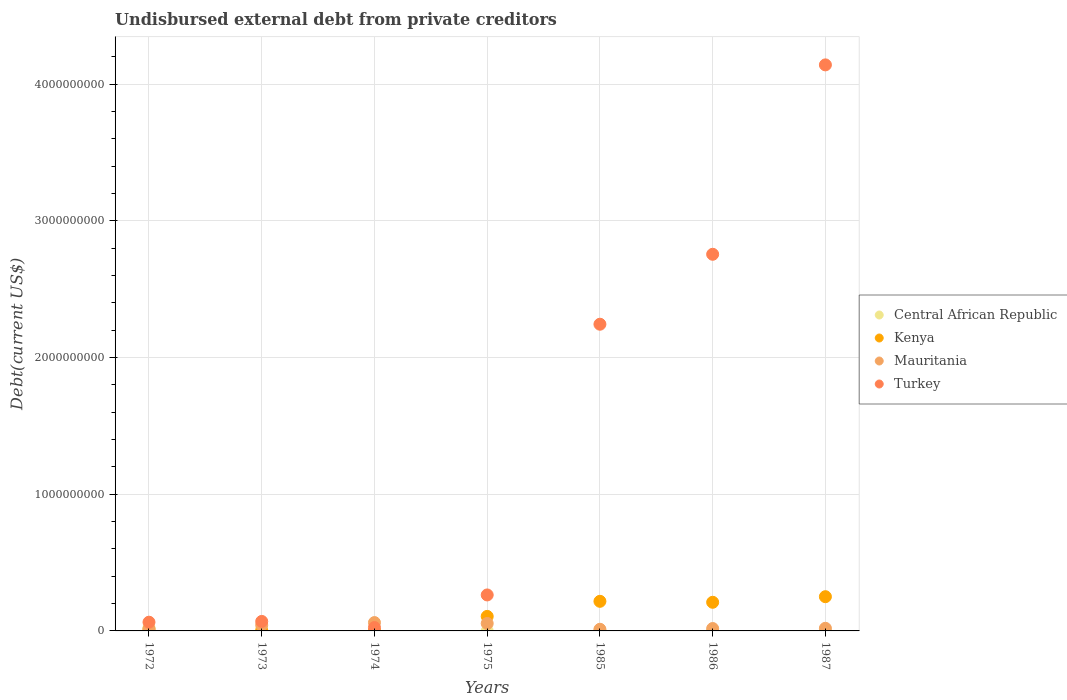Is the number of dotlines equal to the number of legend labels?
Your response must be concise. Yes. What is the total debt in Central African Republic in 1972?
Give a very brief answer. 2.36e+07. Across all years, what is the maximum total debt in Turkey?
Make the answer very short. 4.14e+09. Across all years, what is the minimum total debt in Mauritania?
Provide a short and direct response. 1.20e+07. In which year was the total debt in Kenya maximum?
Your answer should be very brief. 1987. In which year was the total debt in Central African Republic minimum?
Ensure brevity in your answer.  1975. What is the total total debt in Mauritania in the graph?
Keep it short and to the point. 2.21e+08. What is the difference between the total debt in Mauritania in 1972 and that in 1975?
Your answer should be very brief. -3.99e+07. What is the difference between the total debt in Kenya in 1973 and the total debt in Central African Republic in 1975?
Your response must be concise. 1.05e+06. What is the average total debt in Central African Republic per year?
Ensure brevity in your answer.  5.42e+06. In the year 1974, what is the difference between the total debt in Central African Republic and total debt in Kenya?
Offer a terse response. 9.98e+05. In how many years, is the total debt in Central African Republic greater than 2000000000 US$?
Offer a very short reply. 0. What is the ratio of the total debt in Kenya in 1973 to that in 1986?
Provide a succinct answer. 0.01. What is the difference between the highest and the second highest total debt in Mauritania?
Provide a succinct answer. 6.54e+06. What is the difference between the highest and the lowest total debt in Turkey?
Offer a terse response. 4.12e+09. In how many years, is the total debt in Turkey greater than the average total debt in Turkey taken over all years?
Ensure brevity in your answer.  3. Is it the case that in every year, the sum of the total debt in Central African Republic and total debt in Mauritania  is greater than the total debt in Kenya?
Your answer should be compact. No. How many dotlines are there?
Give a very brief answer. 4. How many years are there in the graph?
Offer a terse response. 7. What is the difference between two consecutive major ticks on the Y-axis?
Your answer should be very brief. 1.00e+09. Are the values on the major ticks of Y-axis written in scientific E-notation?
Your answer should be compact. No. Does the graph contain any zero values?
Offer a very short reply. No. How many legend labels are there?
Ensure brevity in your answer.  4. How are the legend labels stacked?
Give a very brief answer. Vertical. What is the title of the graph?
Give a very brief answer. Undisbursed external debt from private creditors. What is the label or title of the Y-axis?
Provide a short and direct response. Debt(current US$). What is the Debt(current US$) of Central African Republic in 1972?
Provide a short and direct response. 2.36e+07. What is the Debt(current US$) in Kenya in 1972?
Keep it short and to the point. 1.02e+07. What is the Debt(current US$) in Mauritania in 1972?
Your response must be concise. 1.46e+07. What is the Debt(current US$) of Turkey in 1972?
Offer a terse response. 6.39e+07. What is the Debt(current US$) of Central African Republic in 1973?
Offer a terse response. 7.28e+06. What is the Debt(current US$) of Kenya in 1973?
Keep it short and to the point. 1.21e+06. What is the Debt(current US$) in Mauritania in 1973?
Your answer should be very brief. 4.22e+07. What is the Debt(current US$) of Turkey in 1973?
Your answer should be compact. 6.95e+07. What is the Debt(current US$) of Central African Republic in 1974?
Your answer should be compact. 1.28e+06. What is the Debt(current US$) in Kenya in 1974?
Make the answer very short. 2.87e+05. What is the Debt(current US$) of Mauritania in 1974?
Provide a short and direct response. 6.10e+07. What is the Debt(current US$) in Turkey in 1974?
Make the answer very short. 2.46e+07. What is the Debt(current US$) in Central African Republic in 1975?
Provide a short and direct response. 1.62e+05. What is the Debt(current US$) in Kenya in 1975?
Make the answer very short. 1.06e+08. What is the Debt(current US$) in Mauritania in 1975?
Provide a short and direct response. 5.45e+07. What is the Debt(current US$) of Turkey in 1975?
Keep it short and to the point. 2.63e+08. What is the Debt(current US$) in Central African Republic in 1985?
Provide a short and direct response. 2.37e+06. What is the Debt(current US$) in Kenya in 1985?
Your response must be concise. 2.17e+08. What is the Debt(current US$) of Mauritania in 1985?
Provide a short and direct response. 1.20e+07. What is the Debt(current US$) of Turkey in 1985?
Your answer should be very brief. 2.24e+09. What is the Debt(current US$) of Central African Republic in 1986?
Keep it short and to the point. 1.96e+06. What is the Debt(current US$) of Kenya in 1986?
Provide a short and direct response. 2.09e+08. What is the Debt(current US$) in Mauritania in 1986?
Your answer should be compact. 1.75e+07. What is the Debt(current US$) of Turkey in 1986?
Your answer should be compact. 2.76e+09. What is the Debt(current US$) in Central African Republic in 1987?
Provide a short and direct response. 1.33e+06. What is the Debt(current US$) of Kenya in 1987?
Your answer should be compact. 2.50e+08. What is the Debt(current US$) of Mauritania in 1987?
Ensure brevity in your answer.  1.92e+07. What is the Debt(current US$) in Turkey in 1987?
Your answer should be compact. 4.14e+09. Across all years, what is the maximum Debt(current US$) in Central African Republic?
Ensure brevity in your answer.  2.36e+07. Across all years, what is the maximum Debt(current US$) in Kenya?
Ensure brevity in your answer.  2.50e+08. Across all years, what is the maximum Debt(current US$) of Mauritania?
Provide a succinct answer. 6.10e+07. Across all years, what is the maximum Debt(current US$) of Turkey?
Offer a very short reply. 4.14e+09. Across all years, what is the minimum Debt(current US$) in Central African Republic?
Keep it short and to the point. 1.62e+05. Across all years, what is the minimum Debt(current US$) of Kenya?
Give a very brief answer. 2.87e+05. Across all years, what is the minimum Debt(current US$) of Mauritania?
Make the answer very short. 1.20e+07. Across all years, what is the minimum Debt(current US$) of Turkey?
Ensure brevity in your answer.  2.46e+07. What is the total Debt(current US$) of Central African Republic in the graph?
Ensure brevity in your answer.  3.80e+07. What is the total Debt(current US$) of Kenya in the graph?
Provide a succinct answer. 7.94e+08. What is the total Debt(current US$) of Mauritania in the graph?
Offer a terse response. 2.21e+08. What is the total Debt(current US$) of Turkey in the graph?
Your answer should be compact. 9.56e+09. What is the difference between the Debt(current US$) of Central African Republic in 1972 and that in 1973?
Ensure brevity in your answer.  1.63e+07. What is the difference between the Debt(current US$) of Kenya in 1972 and that in 1973?
Your answer should be very brief. 8.96e+06. What is the difference between the Debt(current US$) of Mauritania in 1972 and that in 1973?
Offer a terse response. -2.76e+07. What is the difference between the Debt(current US$) in Turkey in 1972 and that in 1973?
Give a very brief answer. -5.62e+06. What is the difference between the Debt(current US$) of Central African Republic in 1972 and that in 1974?
Ensure brevity in your answer.  2.23e+07. What is the difference between the Debt(current US$) in Kenya in 1972 and that in 1974?
Offer a very short reply. 9.88e+06. What is the difference between the Debt(current US$) of Mauritania in 1972 and that in 1974?
Your answer should be compact. -4.65e+07. What is the difference between the Debt(current US$) in Turkey in 1972 and that in 1974?
Your answer should be very brief. 3.93e+07. What is the difference between the Debt(current US$) in Central African Republic in 1972 and that in 1975?
Provide a short and direct response. 2.34e+07. What is the difference between the Debt(current US$) of Kenya in 1972 and that in 1975?
Offer a very short reply. -9.60e+07. What is the difference between the Debt(current US$) of Mauritania in 1972 and that in 1975?
Your response must be concise. -3.99e+07. What is the difference between the Debt(current US$) of Turkey in 1972 and that in 1975?
Keep it short and to the point. -1.99e+08. What is the difference between the Debt(current US$) in Central African Republic in 1972 and that in 1985?
Offer a terse response. 2.12e+07. What is the difference between the Debt(current US$) of Kenya in 1972 and that in 1985?
Offer a very short reply. -2.06e+08. What is the difference between the Debt(current US$) of Mauritania in 1972 and that in 1985?
Offer a terse response. 2.56e+06. What is the difference between the Debt(current US$) of Turkey in 1972 and that in 1985?
Provide a short and direct response. -2.18e+09. What is the difference between the Debt(current US$) in Central African Republic in 1972 and that in 1986?
Provide a short and direct response. 2.16e+07. What is the difference between the Debt(current US$) in Kenya in 1972 and that in 1986?
Provide a short and direct response. -1.99e+08. What is the difference between the Debt(current US$) in Mauritania in 1972 and that in 1986?
Offer a very short reply. -2.92e+06. What is the difference between the Debt(current US$) in Turkey in 1972 and that in 1986?
Give a very brief answer. -2.69e+09. What is the difference between the Debt(current US$) of Central African Republic in 1972 and that in 1987?
Keep it short and to the point. 2.23e+07. What is the difference between the Debt(current US$) in Kenya in 1972 and that in 1987?
Ensure brevity in your answer.  -2.40e+08. What is the difference between the Debt(current US$) in Mauritania in 1972 and that in 1987?
Make the answer very short. -4.64e+06. What is the difference between the Debt(current US$) of Turkey in 1972 and that in 1987?
Offer a very short reply. -4.08e+09. What is the difference between the Debt(current US$) in Central African Republic in 1973 and that in 1974?
Provide a short and direct response. 6.00e+06. What is the difference between the Debt(current US$) in Kenya in 1973 and that in 1974?
Offer a very short reply. 9.26e+05. What is the difference between the Debt(current US$) in Mauritania in 1973 and that in 1974?
Make the answer very short. -1.89e+07. What is the difference between the Debt(current US$) in Turkey in 1973 and that in 1974?
Your response must be concise. 4.49e+07. What is the difference between the Debt(current US$) in Central African Republic in 1973 and that in 1975?
Your response must be concise. 7.12e+06. What is the difference between the Debt(current US$) of Kenya in 1973 and that in 1975?
Ensure brevity in your answer.  -1.05e+08. What is the difference between the Debt(current US$) of Mauritania in 1973 and that in 1975?
Offer a very short reply. -1.23e+07. What is the difference between the Debt(current US$) in Turkey in 1973 and that in 1975?
Provide a short and direct response. -1.94e+08. What is the difference between the Debt(current US$) of Central African Republic in 1973 and that in 1985?
Offer a terse response. 4.91e+06. What is the difference between the Debt(current US$) in Kenya in 1973 and that in 1985?
Provide a succinct answer. -2.15e+08. What is the difference between the Debt(current US$) of Mauritania in 1973 and that in 1985?
Offer a very short reply. 3.01e+07. What is the difference between the Debt(current US$) of Turkey in 1973 and that in 1985?
Offer a terse response. -2.17e+09. What is the difference between the Debt(current US$) of Central African Republic in 1973 and that in 1986?
Ensure brevity in your answer.  5.33e+06. What is the difference between the Debt(current US$) of Kenya in 1973 and that in 1986?
Your response must be concise. -2.08e+08. What is the difference between the Debt(current US$) in Mauritania in 1973 and that in 1986?
Make the answer very short. 2.47e+07. What is the difference between the Debt(current US$) of Turkey in 1973 and that in 1986?
Keep it short and to the point. -2.69e+09. What is the difference between the Debt(current US$) of Central African Republic in 1973 and that in 1987?
Give a very brief answer. 5.96e+06. What is the difference between the Debt(current US$) of Kenya in 1973 and that in 1987?
Offer a very short reply. -2.49e+08. What is the difference between the Debt(current US$) of Mauritania in 1973 and that in 1987?
Your answer should be very brief. 2.29e+07. What is the difference between the Debt(current US$) in Turkey in 1973 and that in 1987?
Your response must be concise. -4.07e+09. What is the difference between the Debt(current US$) of Central African Republic in 1974 and that in 1975?
Your answer should be very brief. 1.12e+06. What is the difference between the Debt(current US$) of Kenya in 1974 and that in 1975?
Ensure brevity in your answer.  -1.06e+08. What is the difference between the Debt(current US$) in Mauritania in 1974 and that in 1975?
Ensure brevity in your answer.  6.54e+06. What is the difference between the Debt(current US$) of Turkey in 1974 and that in 1975?
Offer a very short reply. -2.39e+08. What is the difference between the Debt(current US$) in Central African Republic in 1974 and that in 1985?
Your answer should be compact. -1.09e+06. What is the difference between the Debt(current US$) of Kenya in 1974 and that in 1985?
Keep it short and to the point. -2.16e+08. What is the difference between the Debt(current US$) of Mauritania in 1974 and that in 1985?
Your response must be concise. 4.90e+07. What is the difference between the Debt(current US$) of Turkey in 1974 and that in 1985?
Your answer should be very brief. -2.22e+09. What is the difference between the Debt(current US$) in Central African Republic in 1974 and that in 1986?
Your answer should be very brief. -6.71e+05. What is the difference between the Debt(current US$) of Kenya in 1974 and that in 1986?
Give a very brief answer. -2.09e+08. What is the difference between the Debt(current US$) in Mauritania in 1974 and that in 1986?
Offer a terse response. 4.35e+07. What is the difference between the Debt(current US$) of Turkey in 1974 and that in 1986?
Ensure brevity in your answer.  -2.73e+09. What is the difference between the Debt(current US$) in Central African Republic in 1974 and that in 1987?
Keep it short and to the point. -4.30e+04. What is the difference between the Debt(current US$) of Kenya in 1974 and that in 1987?
Keep it short and to the point. -2.50e+08. What is the difference between the Debt(current US$) of Mauritania in 1974 and that in 1987?
Ensure brevity in your answer.  4.18e+07. What is the difference between the Debt(current US$) in Turkey in 1974 and that in 1987?
Offer a very short reply. -4.12e+09. What is the difference between the Debt(current US$) in Central African Republic in 1975 and that in 1985?
Provide a short and direct response. -2.21e+06. What is the difference between the Debt(current US$) in Kenya in 1975 and that in 1985?
Offer a very short reply. -1.10e+08. What is the difference between the Debt(current US$) of Mauritania in 1975 and that in 1985?
Provide a short and direct response. 4.25e+07. What is the difference between the Debt(current US$) in Turkey in 1975 and that in 1985?
Your answer should be compact. -1.98e+09. What is the difference between the Debt(current US$) of Central African Republic in 1975 and that in 1986?
Keep it short and to the point. -1.79e+06. What is the difference between the Debt(current US$) of Kenya in 1975 and that in 1986?
Ensure brevity in your answer.  -1.03e+08. What is the difference between the Debt(current US$) of Mauritania in 1975 and that in 1986?
Offer a terse response. 3.70e+07. What is the difference between the Debt(current US$) in Turkey in 1975 and that in 1986?
Your response must be concise. -2.49e+09. What is the difference between the Debt(current US$) of Central African Republic in 1975 and that in 1987?
Provide a short and direct response. -1.17e+06. What is the difference between the Debt(current US$) of Kenya in 1975 and that in 1987?
Your answer should be compact. -1.44e+08. What is the difference between the Debt(current US$) in Mauritania in 1975 and that in 1987?
Provide a succinct answer. 3.53e+07. What is the difference between the Debt(current US$) in Turkey in 1975 and that in 1987?
Provide a succinct answer. -3.88e+09. What is the difference between the Debt(current US$) of Central African Republic in 1985 and that in 1986?
Your answer should be compact. 4.17e+05. What is the difference between the Debt(current US$) in Kenya in 1985 and that in 1986?
Keep it short and to the point. 7.08e+06. What is the difference between the Debt(current US$) of Mauritania in 1985 and that in 1986?
Your response must be concise. -5.48e+06. What is the difference between the Debt(current US$) in Turkey in 1985 and that in 1986?
Give a very brief answer. -5.12e+08. What is the difference between the Debt(current US$) in Central African Republic in 1985 and that in 1987?
Make the answer very short. 1.04e+06. What is the difference between the Debt(current US$) in Kenya in 1985 and that in 1987?
Your answer should be very brief. -3.38e+07. What is the difference between the Debt(current US$) in Mauritania in 1985 and that in 1987?
Give a very brief answer. -7.21e+06. What is the difference between the Debt(current US$) in Turkey in 1985 and that in 1987?
Your response must be concise. -1.90e+09. What is the difference between the Debt(current US$) of Central African Republic in 1986 and that in 1987?
Ensure brevity in your answer.  6.28e+05. What is the difference between the Debt(current US$) of Kenya in 1986 and that in 1987?
Provide a short and direct response. -4.09e+07. What is the difference between the Debt(current US$) of Mauritania in 1986 and that in 1987?
Offer a very short reply. -1.73e+06. What is the difference between the Debt(current US$) of Turkey in 1986 and that in 1987?
Your answer should be very brief. -1.39e+09. What is the difference between the Debt(current US$) of Central African Republic in 1972 and the Debt(current US$) of Kenya in 1973?
Ensure brevity in your answer.  2.24e+07. What is the difference between the Debt(current US$) of Central African Republic in 1972 and the Debt(current US$) of Mauritania in 1973?
Ensure brevity in your answer.  -1.86e+07. What is the difference between the Debt(current US$) of Central African Republic in 1972 and the Debt(current US$) of Turkey in 1973?
Your answer should be compact. -4.59e+07. What is the difference between the Debt(current US$) in Kenya in 1972 and the Debt(current US$) in Mauritania in 1973?
Your answer should be very brief. -3.20e+07. What is the difference between the Debt(current US$) of Kenya in 1972 and the Debt(current US$) of Turkey in 1973?
Make the answer very short. -5.93e+07. What is the difference between the Debt(current US$) of Mauritania in 1972 and the Debt(current US$) of Turkey in 1973?
Offer a very short reply. -5.49e+07. What is the difference between the Debt(current US$) of Central African Republic in 1972 and the Debt(current US$) of Kenya in 1974?
Offer a terse response. 2.33e+07. What is the difference between the Debt(current US$) of Central African Republic in 1972 and the Debt(current US$) of Mauritania in 1974?
Offer a very short reply. -3.75e+07. What is the difference between the Debt(current US$) in Central African Republic in 1972 and the Debt(current US$) in Turkey in 1974?
Your response must be concise. -1.01e+06. What is the difference between the Debt(current US$) in Kenya in 1972 and the Debt(current US$) in Mauritania in 1974?
Offer a very short reply. -5.09e+07. What is the difference between the Debt(current US$) in Kenya in 1972 and the Debt(current US$) in Turkey in 1974?
Give a very brief answer. -1.44e+07. What is the difference between the Debt(current US$) in Mauritania in 1972 and the Debt(current US$) in Turkey in 1974?
Keep it short and to the point. -1.00e+07. What is the difference between the Debt(current US$) of Central African Republic in 1972 and the Debt(current US$) of Kenya in 1975?
Your answer should be compact. -8.26e+07. What is the difference between the Debt(current US$) of Central African Republic in 1972 and the Debt(current US$) of Mauritania in 1975?
Make the answer very short. -3.09e+07. What is the difference between the Debt(current US$) of Central African Republic in 1972 and the Debt(current US$) of Turkey in 1975?
Keep it short and to the point. -2.40e+08. What is the difference between the Debt(current US$) of Kenya in 1972 and the Debt(current US$) of Mauritania in 1975?
Provide a succinct answer. -4.43e+07. What is the difference between the Debt(current US$) of Kenya in 1972 and the Debt(current US$) of Turkey in 1975?
Your answer should be compact. -2.53e+08. What is the difference between the Debt(current US$) of Mauritania in 1972 and the Debt(current US$) of Turkey in 1975?
Ensure brevity in your answer.  -2.49e+08. What is the difference between the Debt(current US$) in Central African Republic in 1972 and the Debt(current US$) in Kenya in 1985?
Provide a succinct answer. -1.93e+08. What is the difference between the Debt(current US$) of Central African Republic in 1972 and the Debt(current US$) of Mauritania in 1985?
Provide a succinct answer. 1.16e+07. What is the difference between the Debt(current US$) of Central African Republic in 1972 and the Debt(current US$) of Turkey in 1985?
Provide a succinct answer. -2.22e+09. What is the difference between the Debt(current US$) of Kenya in 1972 and the Debt(current US$) of Mauritania in 1985?
Your response must be concise. -1.85e+06. What is the difference between the Debt(current US$) in Kenya in 1972 and the Debt(current US$) in Turkey in 1985?
Offer a very short reply. -2.23e+09. What is the difference between the Debt(current US$) of Mauritania in 1972 and the Debt(current US$) of Turkey in 1985?
Offer a terse response. -2.23e+09. What is the difference between the Debt(current US$) in Central African Republic in 1972 and the Debt(current US$) in Kenya in 1986?
Ensure brevity in your answer.  -1.86e+08. What is the difference between the Debt(current US$) of Central African Republic in 1972 and the Debt(current US$) of Mauritania in 1986?
Offer a very short reply. 6.08e+06. What is the difference between the Debt(current US$) in Central African Republic in 1972 and the Debt(current US$) in Turkey in 1986?
Ensure brevity in your answer.  -2.73e+09. What is the difference between the Debt(current US$) in Kenya in 1972 and the Debt(current US$) in Mauritania in 1986?
Offer a very short reply. -7.34e+06. What is the difference between the Debt(current US$) of Kenya in 1972 and the Debt(current US$) of Turkey in 1986?
Offer a terse response. -2.74e+09. What is the difference between the Debt(current US$) of Mauritania in 1972 and the Debt(current US$) of Turkey in 1986?
Keep it short and to the point. -2.74e+09. What is the difference between the Debt(current US$) of Central African Republic in 1972 and the Debt(current US$) of Kenya in 1987?
Provide a short and direct response. -2.27e+08. What is the difference between the Debt(current US$) in Central African Republic in 1972 and the Debt(current US$) in Mauritania in 1987?
Provide a succinct answer. 4.35e+06. What is the difference between the Debt(current US$) of Central African Republic in 1972 and the Debt(current US$) of Turkey in 1987?
Your response must be concise. -4.12e+09. What is the difference between the Debt(current US$) of Kenya in 1972 and the Debt(current US$) of Mauritania in 1987?
Keep it short and to the point. -9.06e+06. What is the difference between the Debt(current US$) in Kenya in 1972 and the Debt(current US$) in Turkey in 1987?
Give a very brief answer. -4.13e+09. What is the difference between the Debt(current US$) in Mauritania in 1972 and the Debt(current US$) in Turkey in 1987?
Offer a very short reply. -4.13e+09. What is the difference between the Debt(current US$) of Central African Republic in 1973 and the Debt(current US$) of Kenya in 1974?
Your answer should be compact. 7.00e+06. What is the difference between the Debt(current US$) in Central African Republic in 1973 and the Debt(current US$) in Mauritania in 1974?
Offer a terse response. -5.38e+07. What is the difference between the Debt(current US$) in Central African Republic in 1973 and the Debt(current US$) in Turkey in 1974?
Make the answer very short. -1.73e+07. What is the difference between the Debt(current US$) of Kenya in 1973 and the Debt(current US$) of Mauritania in 1974?
Make the answer very short. -5.98e+07. What is the difference between the Debt(current US$) in Kenya in 1973 and the Debt(current US$) in Turkey in 1974?
Keep it short and to the point. -2.34e+07. What is the difference between the Debt(current US$) in Mauritania in 1973 and the Debt(current US$) in Turkey in 1974?
Keep it short and to the point. 1.76e+07. What is the difference between the Debt(current US$) of Central African Republic in 1973 and the Debt(current US$) of Kenya in 1975?
Provide a short and direct response. -9.89e+07. What is the difference between the Debt(current US$) of Central African Republic in 1973 and the Debt(current US$) of Mauritania in 1975?
Offer a very short reply. -4.72e+07. What is the difference between the Debt(current US$) of Central African Republic in 1973 and the Debt(current US$) of Turkey in 1975?
Offer a terse response. -2.56e+08. What is the difference between the Debt(current US$) of Kenya in 1973 and the Debt(current US$) of Mauritania in 1975?
Offer a terse response. -5.33e+07. What is the difference between the Debt(current US$) of Kenya in 1973 and the Debt(current US$) of Turkey in 1975?
Make the answer very short. -2.62e+08. What is the difference between the Debt(current US$) in Mauritania in 1973 and the Debt(current US$) in Turkey in 1975?
Your answer should be compact. -2.21e+08. What is the difference between the Debt(current US$) of Central African Republic in 1973 and the Debt(current US$) of Kenya in 1985?
Make the answer very short. -2.09e+08. What is the difference between the Debt(current US$) of Central African Republic in 1973 and the Debt(current US$) of Mauritania in 1985?
Provide a succinct answer. -4.74e+06. What is the difference between the Debt(current US$) in Central African Republic in 1973 and the Debt(current US$) in Turkey in 1985?
Ensure brevity in your answer.  -2.24e+09. What is the difference between the Debt(current US$) of Kenya in 1973 and the Debt(current US$) of Mauritania in 1985?
Provide a succinct answer. -1.08e+07. What is the difference between the Debt(current US$) of Kenya in 1973 and the Debt(current US$) of Turkey in 1985?
Provide a succinct answer. -2.24e+09. What is the difference between the Debt(current US$) in Mauritania in 1973 and the Debt(current US$) in Turkey in 1985?
Your answer should be compact. -2.20e+09. What is the difference between the Debt(current US$) of Central African Republic in 1973 and the Debt(current US$) of Kenya in 1986?
Make the answer very short. -2.02e+08. What is the difference between the Debt(current US$) of Central African Republic in 1973 and the Debt(current US$) of Mauritania in 1986?
Your answer should be very brief. -1.02e+07. What is the difference between the Debt(current US$) of Central African Republic in 1973 and the Debt(current US$) of Turkey in 1986?
Provide a short and direct response. -2.75e+09. What is the difference between the Debt(current US$) of Kenya in 1973 and the Debt(current US$) of Mauritania in 1986?
Your answer should be compact. -1.63e+07. What is the difference between the Debt(current US$) in Kenya in 1973 and the Debt(current US$) in Turkey in 1986?
Offer a very short reply. -2.75e+09. What is the difference between the Debt(current US$) of Mauritania in 1973 and the Debt(current US$) of Turkey in 1986?
Provide a succinct answer. -2.71e+09. What is the difference between the Debt(current US$) in Central African Republic in 1973 and the Debt(current US$) in Kenya in 1987?
Your answer should be compact. -2.43e+08. What is the difference between the Debt(current US$) of Central African Republic in 1973 and the Debt(current US$) of Mauritania in 1987?
Keep it short and to the point. -1.19e+07. What is the difference between the Debt(current US$) of Central African Republic in 1973 and the Debt(current US$) of Turkey in 1987?
Your response must be concise. -4.13e+09. What is the difference between the Debt(current US$) of Kenya in 1973 and the Debt(current US$) of Mauritania in 1987?
Offer a very short reply. -1.80e+07. What is the difference between the Debt(current US$) in Kenya in 1973 and the Debt(current US$) in Turkey in 1987?
Your answer should be very brief. -4.14e+09. What is the difference between the Debt(current US$) of Mauritania in 1973 and the Debt(current US$) of Turkey in 1987?
Your response must be concise. -4.10e+09. What is the difference between the Debt(current US$) in Central African Republic in 1974 and the Debt(current US$) in Kenya in 1975?
Give a very brief answer. -1.05e+08. What is the difference between the Debt(current US$) in Central African Republic in 1974 and the Debt(current US$) in Mauritania in 1975?
Offer a terse response. -5.32e+07. What is the difference between the Debt(current US$) in Central African Republic in 1974 and the Debt(current US$) in Turkey in 1975?
Your answer should be very brief. -2.62e+08. What is the difference between the Debt(current US$) of Kenya in 1974 and the Debt(current US$) of Mauritania in 1975?
Your answer should be compact. -5.42e+07. What is the difference between the Debt(current US$) in Kenya in 1974 and the Debt(current US$) in Turkey in 1975?
Provide a short and direct response. -2.63e+08. What is the difference between the Debt(current US$) of Mauritania in 1974 and the Debt(current US$) of Turkey in 1975?
Your answer should be compact. -2.02e+08. What is the difference between the Debt(current US$) in Central African Republic in 1974 and the Debt(current US$) in Kenya in 1985?
Your answer should be compact. -2.15e+08. What is the difference between the Debt(current US$) of Central African Republic in 1974 and the Debt(current US$) of Mauritania in 1985?
Your answer should be compact. -1.07e+07. What is the difference between the Debt(current US$) of Central African Republic in 1974 and the Debt(current US$) of Turkey in 1985?
Make the answer very short. -2.24e+09. What is the difference between the Debt(current US$) in Kenya in 1974 and the Debt(current US$) in Mauritania in 1985?
Give a very brief answer. -1.17e+07. What is the difference between the Debt(current US$) of Kenya in 1974 and the Debt(current US$) of Turkey in 1985?
Give a very brief answer. -2.24e+09. What is the difference between the Debt(current US$) in Mauritania in 1974 and the Debt(current US$) in Turkey in 1985?
Your answer should be compact. -2.18e+09. What is the difference between the Debt(current US$) in Central African Republic in 1974 and the Debt(current US$) in Kenya in 1986?
Ensure brevity in your answer.  -2.08e+08. What is the difference between the Debt(current US$) in Central African Republic in 1974 and the Debt(current US$) in Mauritania in 1986?
Give a very brief answer. -1.62e+07. What is the difference between the Debt(current US$) of Central African Republic in 1974 and the Debt(current US$) of Turkey in 1986?
Keep it short and to the point. -2.75e+09. What is the difference between the Debt(current US$) of Kenya in 1974 and the Debt(current US$) of Mauritania in 1986?
Your response must be concise. -1.72e+07. What is the difference between the Debt(current US$) in Kenya in 1974 and the Debt(current US$) in Turkey in 1986?
Offer a very short reply. -2.75e+09. What is the difference between the Debt(current US$) of Mauritania in 1974 and the Debt(current US$) of Turkey in 1986?
Provide a short and direct response. -2.69e+09. What is the difference between the Debt(current US$) in Central African Republic in 1974 and the Debt(current US$) in Kenya in 1987?
Your answer should be very brief. -2.49e+08. What is the difference between the Debt(current US$) of Central African Republic in 1974 and the Debt(current US$) of Mauritania in 1987?
Provide a succinct answer. -1.79e+07. What is the difference between the Debt(current US$) of Central African Republic in 1974 and the Debt(current US$) of Turkey in 1987?
Ensure brevity in your answer.  -4.14e+09. What is the difference between the Debt(current US$) of Kenya in 1974 and the Debt(current US$) of Mauritania in 1987?
Ensure brevity in your answer.  -1.89e+07. What is the difference between the Debt(current US$) in Kenya in 1974 and the Debt(current US$) in Turkey in 1987?
Give a very brief answer. -4.14e+09. What is the difference between the Debt(current US$) of Mauritania in 1974 and the Debt(current US$) of Turkey in 1987?
Your answer should be very brief. -4.08e+09. What is the difference between the Debt(current US$) of Central African Republic in 1975 and the Debt(current US$) of Kenya in 1985?
Offer a very short reply. -2.16e+08. What is the difference between the Debt(current US$) in Central African Republic in 1975 and the Debt(current US$) in Mauritania in 1985?
Keep it short and to the point. -1.19e+07. What is the difference between the Debt(current US$) of Central African Republic in 1975 and the Debt(current US$) of Turkey in 1985?
Offer a very short reply. -2.24e+09. What is the difference between the Debt(current US$) of Kenya in 1975 and the Debt(current US$) of Mauritania in 1985?
Provide a short and direct response. 9.42e+07. What is the difference between the Debt(current US$) of Kenya in 1975 and the Debt(current US$) of Turkey in 1985?
Provide a succinct answer. -2.14e+09. What is the difference between the Debt(current US$) in Mauritania in 1975 and the Debt(current US$) in Turkey in 1985?
Offer a very short reply. -2.19e+09. What is the difference between the Debt(current US$) in Central African Republic in 1975 and the Debt(current US$) in Kenya in 1986?
Make the answer very short. -2.09e+08. What is the difference between the Debt(current US$) in Central African Republic in 1975 and the Debt(current US$) in Mauritania in 1986?
Your answer should be compact. -1.73e+07. What is the difference between the Debt(current US$) of Central African Republic in 1975 and the Debt(current US$) of Turkey in 1986?
Provide a short and direct response. -2.76e+09. What is the difference between the Debt(current US$) in Kenya in 1975 and the Debt(current US$) in Mauritania in 1986?
Keep it short and to the point. 8.87e+07. What is the difference between the Debt(current US$) of Kenya in 1975 and the Debt(current US$) of Turkey in 1986?
Provide a short and direct response. -2.65e+09. What is the difference between the Debt(current US$) of Mauritania in 1975 and the Debt(current US$) of Turkey in 1986?
Your answer should be compact. -2.70e+09. What is the difference between the Debt(current US$) in Central African Republic in 1975 and the Debt(current US$) in Kenya in 1987?
Your response must be concise. -2.50e+08. What is the difference between the Debt(current US$) of Central African Republic in 1975 and the Debt(current US$) of Mauritania in 1987?
Ensure brevity in your answer.  -1.91e+07. What is the difference between the Debt(current US$) in Central African Republic in 1975 and the Debt(current US$) in Turkey in 1987?
Offer a very short reply. -4.14e+09. What is the difference between the Debt(current US$) in Kenya in 1975 and the Debt(current US$) in Mauritania in 1987?
Offer a terse response. 8.70e+07. What is the difference between the Debt(current US$) in Kenya in 1975 and the Debt(current US$) in Turkey in 1987?
Ensure brevity in your answer.  -4.03e+09. What is the difference between the Debt(current US$) of Mauritania in 1975 and the Debt(current US$) of Turkey in 1987?
Your answer should be very brief. -4.09e+09. What is the difference between the Debt(current US$) in Central African Republic in 1985 and the Debt(current US$) in Kenya in 1986?
Provide a short and direct response. -2.07e+08. What is the difference between the Debt(current US$) in Central African Republic in 1985 and the Debt(current US$) in Mauritania in 1986?
Your answer should be compact. -1.51e+07. What is the difference between the Debt(current US$) of Central African Republic in 1985 and the Debt(current US$) of Turkey in 1986?
Offer a terse response. -2.75e+09. What is the difference between the Debt(current US$) in Kenya in 1985 and the Debt(current US$) in Mauritania in 1986?
Your answer should be compact. 1.99e+08. What is the difference between the Debt(current US$) in Kenya in 1985 and the Debt(current US$) in Turkey in 1986?
Offer a very short reply. -2.54e+09. What is the difference between the Debt(current US$) of Mauritania in 1985 and the Debt(current US$) of Turkey in 1986?
Provide a short and direct response. -2.74e+09. What is the difference between the Debt(current US$) in Central African Republic in 1985 and the Debt(current US$) in Kenya in 1987?
Your answer should be very brief. -2.48e+08. What is the difference between the Debt(current US$) of Central African Republic in 1985 and the Debt(current US$) of Mauritania in 1987?
Offer a terse response. -1.69e+07. What is the difference between the Debt(current US$) of Central African Republic in 1985 and the Debt(current US$) of Turkey in 1987?
Ensure brevity in your answer.  -4.14e+09. What is the difference between the Debt(current US$) of Kenya in 1985 and the Debt(current US$) of Mauritania in 1987?
Your answer should be compact. 1.97e+08. What is the difference between the Debt(current US$) in Kenya in 1985 and the Debt(current US$) in Turkey in 1987?
Provide a succinct answer. -3.92e+09. What is the difference between the Debt(current US$) in Mauritania in 1985 and the Debt(current US$) in Turkey in 1987?
Offer a very short reply. -4.13e+09. What is the difference between the Debt(current US$) in Central African Republic in 1986 and the Debt(current US$) in Kenya in 1987?
Give a very brief answer. -2.48e+08. What is the difference between the Debt(current US$) of Central African Republic in 1986 and the Debt(current US$) of Mauritania in 1987?
Provide a succinct answer. -1.73e+07. What is the difference between the Debt(current US$) in Central African Republic in 1986 and the Debt(current US$) in Turkey in 1987?
Your answer should be very brief. -4.14e+09. What is the difference between the Debt(current US$) of Kenya in 1986 and the Debt(current US$) of Mauritania in 1987?
Keep it short and to the point. 1.90e+08. What is the difference between the Debt(current US$) in Kenya in 1986 and the Debt(current US$) in Turkey in 1987?
Your answer should be very brief. -3.93e+09. What is the difference between the Debt(current US$) in Mauritania in 1986 and the Debt(current US$) in Turkey in 1987?
Offer a very short reply. -4.12e+09. What is the average Debt(current US$) of Central African Republic per year?
Make the answer very short. 5.42e+06. What is the average Debt(current US$) in Kenya per year?
Your response must be concise. 1.13e+08. What is the average Debt(current US$) of Mauritania per year?
Your answer should be very brief. 3.16e+07. What is the average Debt(current US$) in Turkey per year?
Offer a very short reply. 1.37e+09. In the year 1972, what is the difference between the Debt(current US$) of Central African Republic and Debt(current US$) of Kenya?
Your response must be concise. 1.34e+07. In the year 1972, what is the difference between the Debt(current US$) in Central African Republic and Debt(current US$) in Mauritania?
Your answer should be compact. 9.00e+06. In the year 1972, what is the difference between the Debt(current US$) of Central African Republic and Debt(current US$) of Turkey?
Your answer should be very brief. -4.03e+07. In the year 1972, what is the difference between the Debt(current US$) of Kenya and Debt(current US$) of Mauritania?
Give a very brief answer. -4.42e+06. In the year 1972, what is the difference between the Debt(current US$) in Kenya and Debt(current US$) in Turkey?
Offer a terse response. -5.37e+07. In the year 1972, what is the difference between the Debt(current US$) of Mauritania and Debt(current US$) of Turkey?
Your answer should be compact. -4.93e+07. In the year 1973, what is the difference between the Debt(current US$) in Central African Republic and Debt(current US$) in Kenya?
Your answer should be very brief. 6.07e+06. In the year 1973, what is the difference between the Debt(current US$) of Central African Republic and Debt(current US$) of Mauritania?
Give a very brief answer. -3.49e+07. In the year 1973, what is the difference between the Debt(current US$) of Central African Republic and Debt(current US$) of Turkey?
Offer a very short reply. -6.22e+07. In the year 1973, what is the difference between the Debt(current US$) of Kenya and Debt(current US$) of Mauritania?
Keep it short and to the point. -4.10e+07. In the year 1973, what is the difference between the Debt(current US$) of Kenya and Debt(current US$) of Turkey?
Your answer should be very brief. -6.83e+07. In the year 1973, what is the difference between the Debt(current US$) in Mauritania and Debt(current US$) in Turkey?
Provide a succinct answer. -2.73e+07. In the year 1974, what is the difference between the Debt(current US$) of Central African Republic and Debt(current US$) of Kenya?
Make the answer very short. 9.98e+05. In the year 1974, what is the difference between the Debt(current US$) in Central African Republic and Debt(current US$) in Mauritania?
Your answer should be compact. -5.98e+07. In the year 1974, what is the difference between the Debt(current US$) of Central African Republic and Debt(current US$) of Turkey?
Offer a terse response. -2.33e+07. In the year 1974, what is the difference between the Debt(current US$) of Kenya and Debt(current US$) of Mauritania?
Provide a short and direct response. -6.08e+07. In the year 1974, what is the difference between the Debt(current US$) of Kenya and Debt(current US$) of Turkey?
Ensure brevity in your answer.  -2.43e+07. In the year 1974, what is the difference between the Debt(current US$) in Mauritania and Debt(current US$) in Turkey?
Make the answer very short. 3.64e+07. In the year 1975, what is the difference between the Debt(current US$) in Central African Republic and Debt(current US$) in Kenya?
Offer a terse response. -1.06e+08. In the year 1975, what is the difference between the Debt(current US$) of Central African Republic and Debt(current US$) of Mauritania?
Your answer should be compact. -5.43e+07. In the year 1975, what is the difference between the Debt(current US$) in Central African Republic and Debt(current US$) in Turkey?
Offer a very short reply. -2.63e+08. In the year 1975, what is the difference between the Debt(current US$) in Kenya and Debt(current US$) in Mauritania?
Make the answer very short. 5.17e+07. In the year 1975, what is the difference between the Debt(current US$) of Kenya and Debt(current US$) of Turkey?
Offer a very short reply. -1.57e+08. In the year 1975, what is the difference between the Debt(current US$) in Mauritania and Debt(current US$) in Turkey?
Make the answer very short. -2.09e+08. In the year 1985, what is the difference between the Debt(current US$) of Central African Republic and Debt(current US$) of Kenya?
Your answer should be compact. -2.14e+08. In the year 1985, what is the difference between the Debt(current US$) of Central African Republic and Debt(current US$) of Mauritania?
Give a very brief answer. -9.65e+06. In the year 1985, what is the difference between the Debt(current US$) in Central African Republic and Debt(current US$) in Turkey?
Ensure brevity in your answer.  -2.24e+09. In the year 1985, what is the difference between the Debt(current US$) in Kenya and Debt(current US$) in Mauritania?
Give a very brief answer. 2.05e+08. In the year 1985, what is the difference between the Debt(current US$) in Kenya and Debt(current US$) in Turkey?
Give a very brief answer. -2.03e+09. In the year 1985, what is the difference between the Debt(current US$) of Mauritania and Debt(current US$) of Turkey?
Ensure brevity in your answer.  -2.23e+09. In the year 1986, what is the difference between the Debt(current US$) in Central African Republic and Debt(current US$) in Kenya?
Make the answer very short. -2.08e+08. In the year 1986, what is the difference between the Debt(current US$) in Central African Republic and Debt(current US$) in Mauritania?
Provide a succinct answer. -1.56e+07. In the year 1986, what is the difference between the Debt(current US$) in Central African Republic and Debt(current US$) in Turkey?
Offer a terse response. -2.75e+09. In the year 1986, what is the difference between the Debt(current US$) in Kenya and Debt(current US$) in Mauritania?
Keep it short and to the point. 1.92e+08. In the year 1986, what is the difference between the Debt(current US$) of Kenya and Debt(current US$) of Turkey?
Offer a very short reply. -2.55e+09. In the year 1986, what is the difference between the Debt(current US$) of Mauritania and Debt(current US$) of Turkey?
Your answer should be very brief. -2.74e+09. In the year 1987, what is the difference between the Debt(current US$) in Central African Republic and Debt(current US$) in Kenya?
Make the answer very short. -2.49e+08. In the year 1987, what is the difference between the Debt(current US$) in Central African Republic and Debt(current US$) in Mauritania?
Offer a terse response. -1.79e+07. In the year 1987, what is the difference between the Debt(current US$) of Central African Republic and Debt(current US$) of Turkey?
Your answer should be very brief. -4.14e+09. In the year 1987, what is the difference between the Debt(current US$) in Kenya and Debt(current US$) in Mauritania?
Offer a very short reply. 2.31e+08. In the year 1987, what is the difference between the Debt(current US$) of Kenya and Debt(current US$) of Turkey?
Keep it short and to the point. -3.89e+09. In the year 1987, what is the difference between the Debt(current US$) in Mauritania and Debt(current US$) in Turkey?
Provide a short and direct response. -4.12e+09. What is the ratio of the Debt(current US$) of Central African Republic in 1972 to that in 1973?
Provide a short and direct response. 3.24. What is the ratio of the Debt(current US$) of Kenya in 1972 to that in 1973?
Your answer should be very brief. 8.38. What is the ratio of the Debt(current US$) of Mauritania in 1972 to that in 1973?
Your answer should be compact. 0.35. What is the ratio of the Debt(current US$) in Turkey in 1972 to that in 1973?
Ensure brevity in your answer.  0.92. What is the ratio of the Debt(current US$) in Central African Republic in 1972 to that in 1974?
Offer a terse response. 18.35. What is the ratio of the Debt(current US$) of Kenya in 1972 to that in 1974?
Offer a very short reply. 35.44. What is the ratio of the Debt(current US$) in Mauritania in 1972 to that in 1974?
Your response must be concise. 0.24. What is the ratio of the Debt(current US$) of Turkey in 1972 to that in 1974?
Provide a succinct answer. 2.6. What is the ratio of the Debt(current US$) in Central African Republic in 1972 to that in 1975?
Offer a very short reply. 145.59. What is the ratio of the Debt(current US$) of Kenya in 1972 to that in 1975?
Ensure brevity in your answer.  0.1. What is the ratio of the Debt(current US$) of Mauritania in 1972 to that in 1975?
Ensure brevity in your answer.  0.27. What is the ratio of the Debt(current US$) of Turkey in 1972 to that in 1975?
Offer a terse response. 0.24. What is the ratio of the Debt(current US$) of Central African Republic in 1972 to that in 1985?
Give a very brief answer. 9.94. What is the ratio of the Debt(current US$) of Kenya in 1972 to that in 1985?
Keep it short and to the point. 0.05. What is the ratio of the Debt(current US$) of Mauritania in 1972 to that in 1985?
Your response must be concise. 1.21. What is the ratio of the Debt(current US$) in Turkey in 1972 to that in 1985?
Provide a short and direct response. 0.03. What is the ratio of the Debt(current US$) of Central African Republic in 1972 to that in 1986?
Provide a succinct answer. 12.06. What is the ratio of the Debt(current US$) in Kenya in 1972 to that in 1986?
Offer a terse response. 0.05. What is the ratio of the Debt(current US$) in Mauritania in 1972 to that in 1986?
Offer a very short reply. 0.83. What is the ratio of the Debt(current US$) of Turkey in 1972 to that in 1986?
Your response must be concise. 0.02. What is the ratio of the Debt(current US$) in Central African Republic in 1972 to that in 1987?
Your response must be concise. 17.76. What is the ratio of the Debt(current US$) in Kenya in 1972 to that in 1987?
Ensure brevity in your answer.  0.04. What is the ratio of the Debt(current US$) of Mauritania in 1972 to that in 1987?
Ensure brevity in your answer.  0.76. What is the ratio of the Debt(current US$) in Turkey in 1972 to that in 1987?
Offer a very short reply. 0.02. What is the ratio of the Debt(current US$) of Central African Republic in 1973 to that in 1974?
Offer a very short reply. 5.67. What is the ratio of the Debt(current US$) of Kenya in 1973 to that in 1974?
Keep it short and to the point. 4.23. What is the ratio of the Debt(current US$) in Mauritania in 1973 to that in 1974?
Offer a terse response. 0.69. What is the ratio of the Debt(current US$) in Turkey in 1973 to that in 1974?
Ensure brevity in your answer.  2.82. What is the ratio of the Debt(current US$) of Central African Republic in 1973 to that in 1975?
Your answer should be compact. 44.96. What is the ratio of the Debt(current US$) in Kenya in 1973 to that in 1975?
Give a very brief answer. 0.01. What is the ratio of the Debt(current US$) of Mauritania in 1973 to that in 1975?
Your answer should be very brief. 0.77. What is the ratio of the Debt(current US$) in Turkey in 1973 to that in 1975?
Provide a succinct answer. 0.26. What is the ratio of the Debt(current US$) in Central African Republic in 1973 to that in 1985?
Provide a succinct answer. 3.07. What is the ratio of the Debt(current US$) of Kenya in 1973 to that in 1985?
Offer a very short reply. 0.01. What is the ratio of the Debt(current US$) in Mauritania in 1973 to that in 1985?
Offer a very short reply. 3.51. What is the ratio of the Debt(current US$) of Turkey in 1973 to that in 1985?
Make the answer very short. 0.03. What is the ratio of the Debt(current US$) in Central African Republic in 1973 to that in 1986?
Give a very brief answer. 3.72. What is the ratio of the Debt(current US$) of Kenya in 1973 to that in 1986?
Your answer should be very brief. 0.01. What is the ratio of the Debt(current US$) of Mauritania in 1973 to that in 1986?
Your response must be concise. 2.41. What is the ratio of the Debt(current US$) in Turkey in 1973 to that in 1986?
Provide a succinct answer. 0.03. What is the ratio of the Debt(current US$) in Central African Republic in 1973 to that in 1987?
Keep it short and to the point. 5.48. What is the ratio of the Debt(current US$) of Kenya in 1973 to that in 1987?
Ensure brevity in your answer.  0. What is the ratio of the Debt(current US$) of Mauritania in 1973 to that in 1987?
Your answer should be compact. 2.19. What is the ratio of the Debt(current US$) in Turkey in 1973 to that in 1987?
Make the answer very short. 0.02. What is the ratio of the Debt(current US$) of Central African Republic in 1974 to that in 1975?
Your response must be concise. 7.93. What is the ratio of the Debt(current US$) of Kenya in 1974 to that in 1975?
Give a very brief answer. 0. What is the ratio of the Debt(current US$) of Mauritania in 1974 to that in 1975?
Provide a short and direct response. 1.12. What is the ratio of the Debt(current US$) in Turkey in 1974 to that in 1975?
Make the answer very short. 0.09. What is the ratio of the Debt(current US$) in Central African Republic in 1974 to that in 1985?
Give a very brief answer. 0.54. What is the ratio of the Debt(current US$) in Kenya in 1974 to that in 1985?
Offer a very short reply. 0. What is the ratio of the Debt(current US$) in Mauritania in 1974 to that in 1985?
Give a very brief answer. 5.08. What is the ratio of the Debt(current US$) of Turkey in 1974 to that in 1985?
Your answer should be compact. 0.01. What is the ratio of the Debt(current US$) in Central African Republic in 1974 to that in 1986?
Your response must be concise. 0.66. What is the ratio of the Debt(current US$) in Kenya in 1974 to that in 1986?
Your response must be concise. 0. What is the ratio of the Debt(current US$) of Mauritania in 1974 to that in 1986?
Your answer should be compact. 3.49. What is the ratio of the Debt(current US$) of Turkey in 1974 to that in 1986?
Offer a very short reply. 0.01. What is the ratio of the Debt(current US$) of Central African Republic in 1974 to that in 1987?
Provide a short and direct response. 0.97. What is the ratio of the Debt(current US$) in Kenya in 1974 to that in 1987?
Your response must be concise. 0. What is the ratio of the Debt(current US$) of Mauritania in 1974 to that in 1987?
Your response must be concise. 3.17. What is the ratio of the Debt(current US$) of Turkey in 1974 to that in 1987?
Make the answer very short. 0.01. What is the ratio of the Debt(current US$) in Central African Republic in 1975 to that in 1985?
Provide a succinct answer. 0.07. What is the ratio of the Debt(current US$) of Kenya in 1975 to that in 1985?
Your response must be concise. 0.49. What is the ratio of the Debt(current US$) in Mauritania in 1975 to that in 1985?
Your answer should be very brief. 4.53. What is the ratio of the Debt(current US$) of Turkey in 1975 to that in 1985?
Your answer should be very brief. 0.12. What is the ratio of the Debt(current US$) of Central African Republic in 1975 to that in 1986?
Your response must be concise. 0.08. What is the ratio of the Debt(current US$) in Kenya in 1975 to that in 1986?
Provide a short and direct response. 0.51. What is the ratio of the Debt(current US$) of Mauritania in 1975 to that in 1986?
Your answer should be very brief. 3.11. What is the ratio of the Debt(current US$) in Turkey in 1975 to that in 1986?
Provide a short and direct response. 0.1. What is the ratio of the Debt(current US$) of Central African Republic in 1975 to that in 1987?
Your answer should be very brief. 0.12. What is the ratio of the Debt(current US$) in Kenya in 1975 to that in 1987?
Give a very brief answer. 0.42. What is the ratio of the Debt(current US$) of Mauritania in 1975 to that in 1987?
Your response must be concise. 2.83. What is the ratio of the Debt(current US$) of Turkey in 1975 to that in 1987?
Give a very brief answer. 0.06. What is the ratio of the Debt(current US$) of Central African Republic in 1985 to that in 1986?
Provide a succinct answer. 1.21. What is the ratio of the Debt(current US$) in Kenya in 1985 to that in 1986?
Ensure brevity in your answer.  1.03. What is the ratio of the Debt(current US$) in Mauritania in 1985 to that in 1986?
Make the answer very short. 0.69. What is the ratio of the Debt(current US$) in Turkey in 1985 to that in 1986?
Offer a terse response. 0.81. What is the ratio of the Debt(current US$) of Central African Republic in 1985 to that in 1987?
Your answer should be very brief. 1.79. What is the ratio of the Debt(current US$) in Kenya in 1985 to that in 1987?
Your response must be concise. 0.86. What is the ratio of the Debt(current US$) in Mauritania in 1985 to that in 1987?
Ensure brevity in your answer.  0.63. What is the ratio of the Debt(current US$) of Turkey in 1985 to that in 1987?
Keep it short and to the point. 0.54. What is the ratio of the Debt(current US$) of Central African Republic in 1986 to that in 1987?
Make the answer very short. 1.47. What is the ratio of the Debt(current US$) of Kenya in 1986 to that in 1987?
Keep it short and to the point. 0.84. What is the ratio of the Debt(current US$) of Mauritania in 1986 to that in 1987?
Make the answer very short. 0.91. What is the ratio of the Debt(current US$) of Turkey in 1986 to that in 1987?
Make the answer very short. 0.67. What is the difference between the highest and the second highest Debt(current US$) of Central African Republic?
Provide a short and direct response. 1.63e+07. What is the difference between the highest and the second highest Debt(current US$) of Kenya?
Ensure brevity in your answer.  3.38e+07. What is the difference between the highest and the second highest Debt(current US$) of Mauritania?
Your answer should be very brief. 6.54e+06. What is the difference between the highest and the second highest Debt(current US$) of Turkey?
Provide a succinct answer. 1.39e+09. What is the difference between the highest and the lowest Debt(current US$) of Central African Republic?
Offer a terse response. 2.34e+07. What is the difference between the highest and the lowest Debt(current US$) of Kenya?
Keep it short and to the point. 2.50e+08. What is the difference between the highest and the lowest Debt(current US$) of Mauritania?
Keep it short and to the point. 4.90e+07. What is the difference between the highest and the lowest Debt(current US$) of Turkey?
Your answer should be very brief. 4.12e+09. 